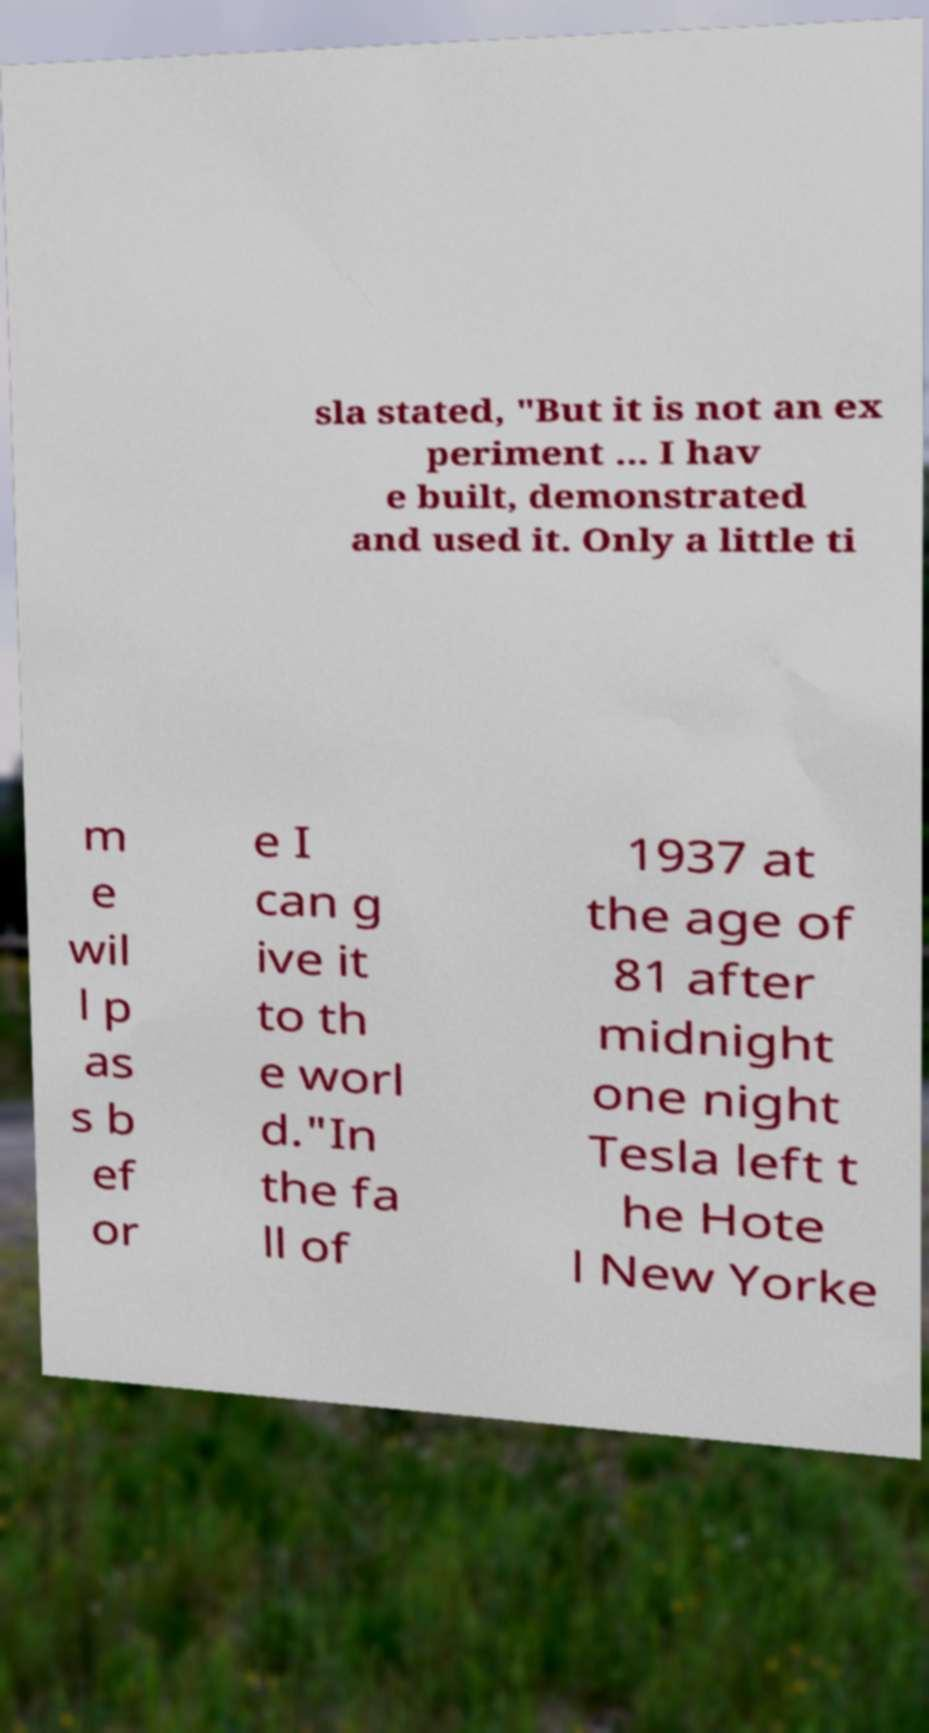Please read and relay the text visible in this image. What does it say? sla stated, "But it is not an ex periment ... I hav e built, demonstrated and used it. Only a little ti m e wil l p as s b ef or e I can g ive it to th e worl d."In the fa ll of 1937 at the age of 81 after midnight one night Tesla left t he Hote l New Yorke 